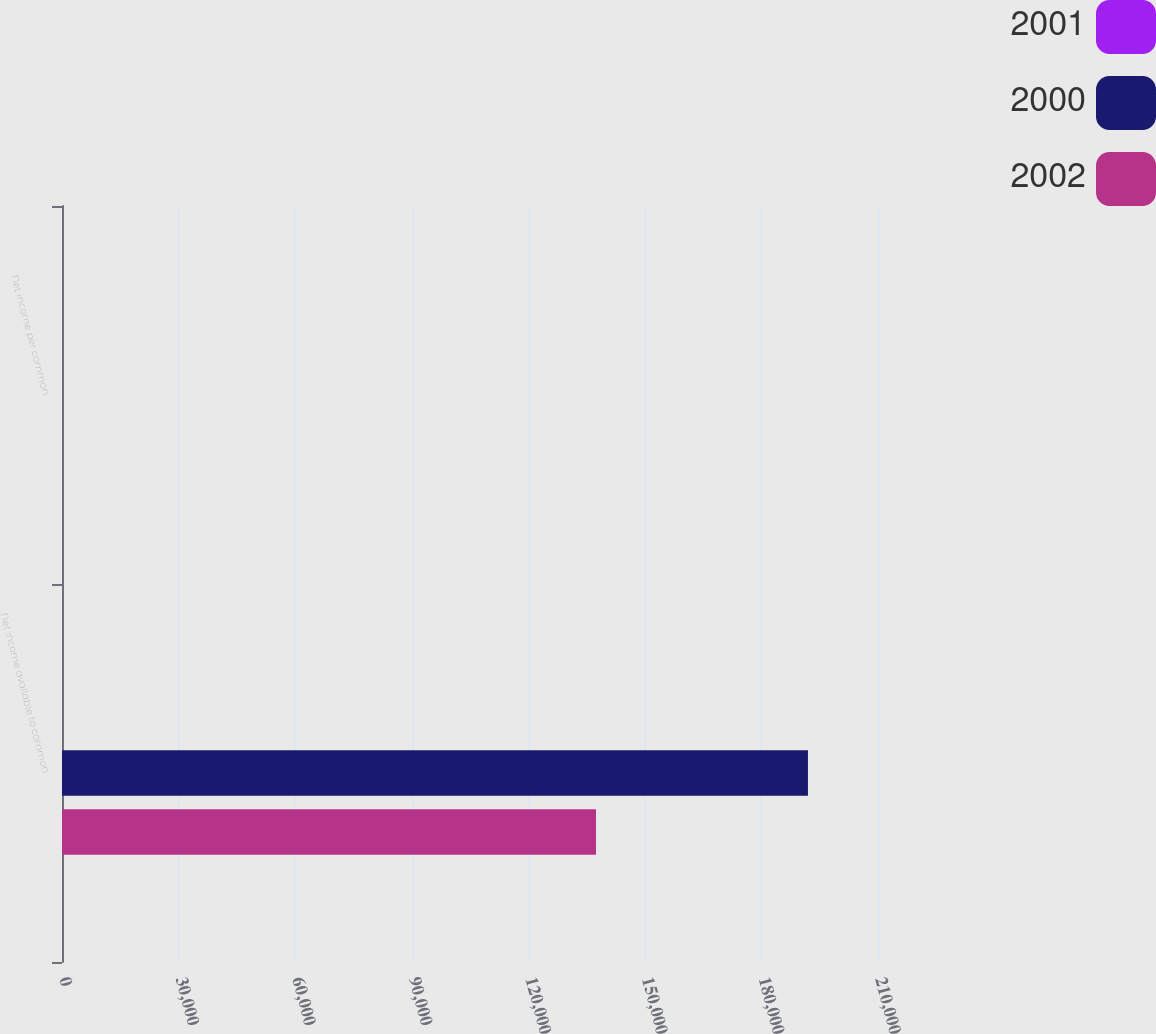Convert chart to OTSL. <chart><loc_0><loc_0><loc_500><loc_500><stacked_bar_chart><ecel><fcel>Net income available to common<fcel>Net income per common<nl><fcel>2001<fcel>3.355<fcel>4.58<nl><fcel>2000<fcel>191973<fcel>2.08<nl><fcel>2002<fcel>137425<fcel>1.89<nl></chart> 